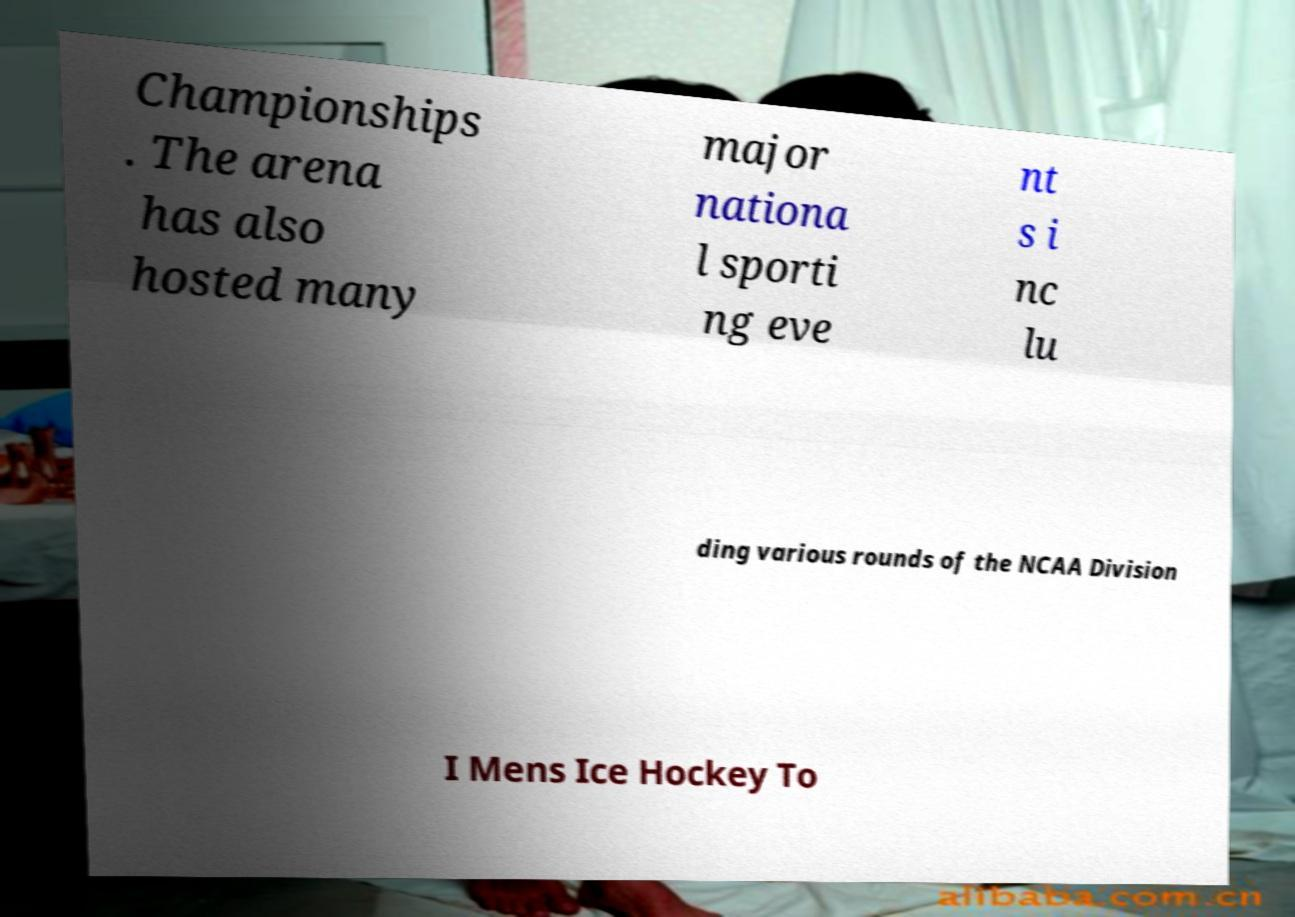Please read and relay the text visible in this image. What does it say? Championships . The arena has also hosted many major nationa l sporti ng eve nt s i nc lu ding various rounds of the NCAA Division I Mens Ice Hockey To 